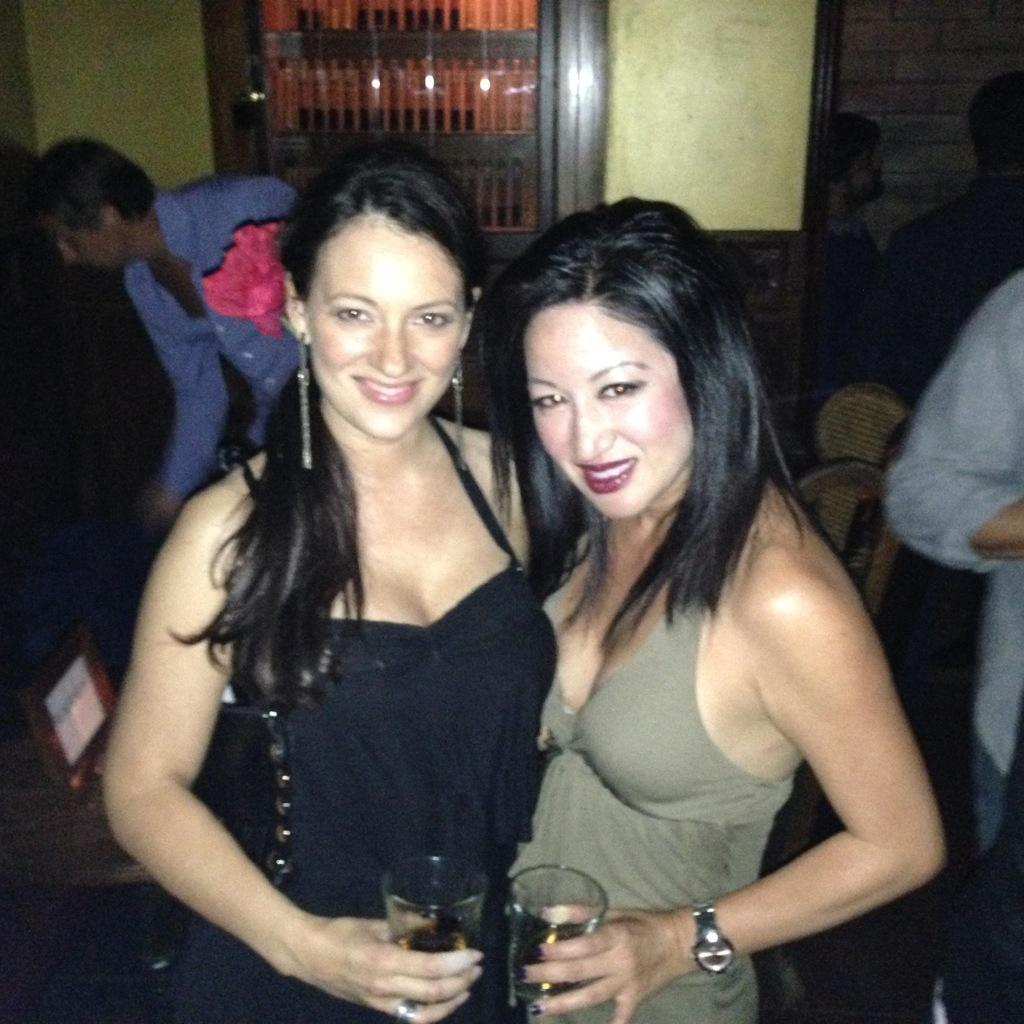What are the women holding in the image? The women are holding glasses in the image. Can you describe the people in the image? There are people in the image, but the specific number or characteristics are not mentioned in the facts. What type of furniture is present in the image? There are chairs in the image. What else can be seen in the image besides the people and chairs? There are objects in a cupboard in the image. What type of government is depicted in the image? There is no reference to a government or any political context in the image. 